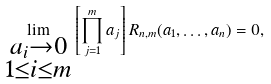Convert formula to latex. <formula><loc_0><loc_0><loc_500><loc_500>\lim _ { \substack { a _ { i } \rightarrow 0 \\ 1 \leq i \leq m } } \left [ \prod _ { j = 1 } ^ { m } a _ { j } \right ] R _ { n , m } ( a _ { 1 } , \dots , a _ { n } ) = 0 ,</formula> 